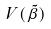<formula> <loc_0><loc_0><loc_500><loc_500>V ( \tilde { \beta } )</formula> 